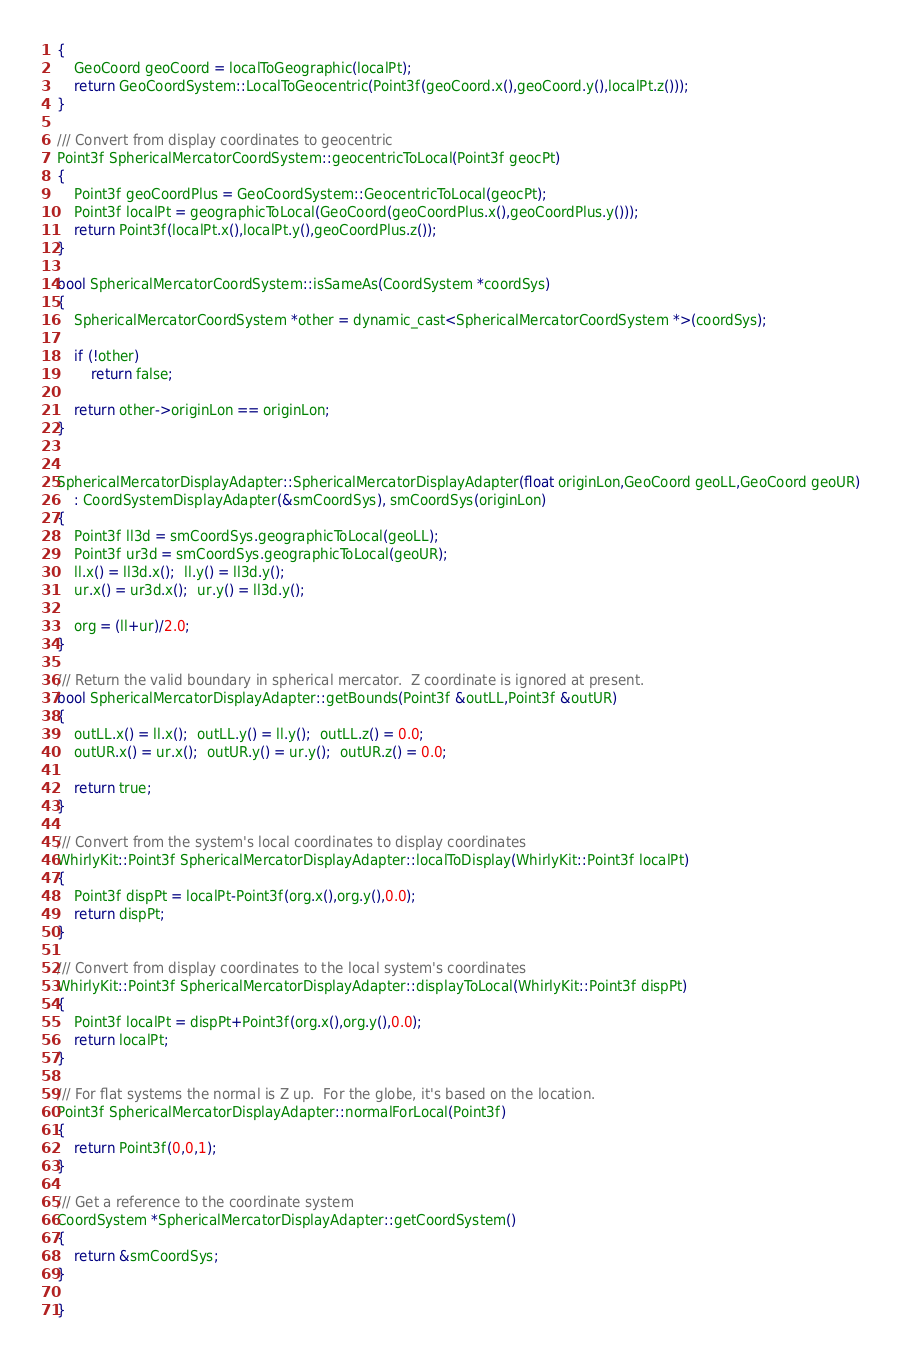Convert code to text. <code><loc_0><loc_0><loc_500><loc_500><_ObjectiveC_>{
    GeoCoord geoCoord = localToGeographic(localPt);
    return GeoCoordSystem::LocalToGeocentric(Point3f(geoCoord.x(),geoCoord.y(),localPt.z()));
}
    
/// Convert from display coordinates to geocentric
Point3f SphericalMercatorCoordSystem::geocentricToLocal(Point3f geocPt)
{
    Point3f geoCoordPlus = GeoCoordSystem::GeocentricToLocal(geocPt);
    Point3f localPt = geographicToLocal(GeoCoord(geoCoordPlus.x(),geoCoordPlus.y()));
    return Point3f(localPt.x(),localPt.y(),geoCoordPlus.z());    
}
    
bool SphericalMercatorCoordSystem::isSameAs(CoordSystem *coordSys)
{
    SphericalMercatorCoordSystem *other = dynamic_cast<SphericalMercatorCoordSystem *>(coordSys);
    
    if (!other)
        return false;
    
    return other->originLon == originLon;
}


SphericalMercatorDisplayAdapter::SphericalMercatorDisplayAdapter(float originLon,GeoCoord geoLL,GeoCoord geoUR)
    : CoordSystemDisplayAdapter(&smCoordSys), smCoordSys(originLon)
{
    Point3f ll3d = smCoordSys.geographicToLocal(geoLL);
    Point3f ur3d = smCoordSys.geographicToLocal(geoUR);
    ll.x() = ll3d.x();  ll.y() = ll3d.y();
    ur.x() = ur3d.x();  ur.y() = ll3d.y();
    
    org = (ll+ur)/2.0;
}
    
/// Return the valid boundary in spherical mercator.  Z coordinate is ignored at present.
bool SphericalMercatorDisplayAdapter::getBounds(Point3f &outLL,Point3f &outUR)
{
    outLL.x() = ll.x();  outLL.y() = ll.y();  outLL.z() = 0.0;
    outUR.x() = ur.x();  outUR.y() = ur.y();  outUR.z() = 0.0;
    
    return true;
}

/// Convert from the system's local coordinates to display coordinates
WhirlyKit::Point3f SphericalMercatorDisplayAdapter::localToDisplay(WhirlyKit::Point3f localPt)
{
    Point3f dispPt = localPt-Point3f(org.x(),org.y(),0.0);
    return dispPt;
}

/// Convert from display coordinates to the local system's coordinates
WhirlyKit::Point3f SphericalMercatorDisplayAdapter::displayToLocal(WhirlyKit::Point3f dispPt)
{
    Point3f localPt = dispPt+Point3f(org.x(),org.y(),0.0);
    return localPt;
}

/// For flat systems the normal is Z up.  For the globe, it's based on the location.
Point3f SphericalMercatorDisplayAdapter::normalForLocal(Point3f)
{
    return Point3f(0,0,1);
}

/// Get a reference to the coordinate system
CoordSystem *SphericalMercatorDisplayAdapter::getCoordSystem()
{
    return &smCoordSys;
}

}
</code> 